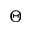Convert formula to latex. <formula><loc_0><loc_0><loc_500><loc_500>\Theta</formula> 